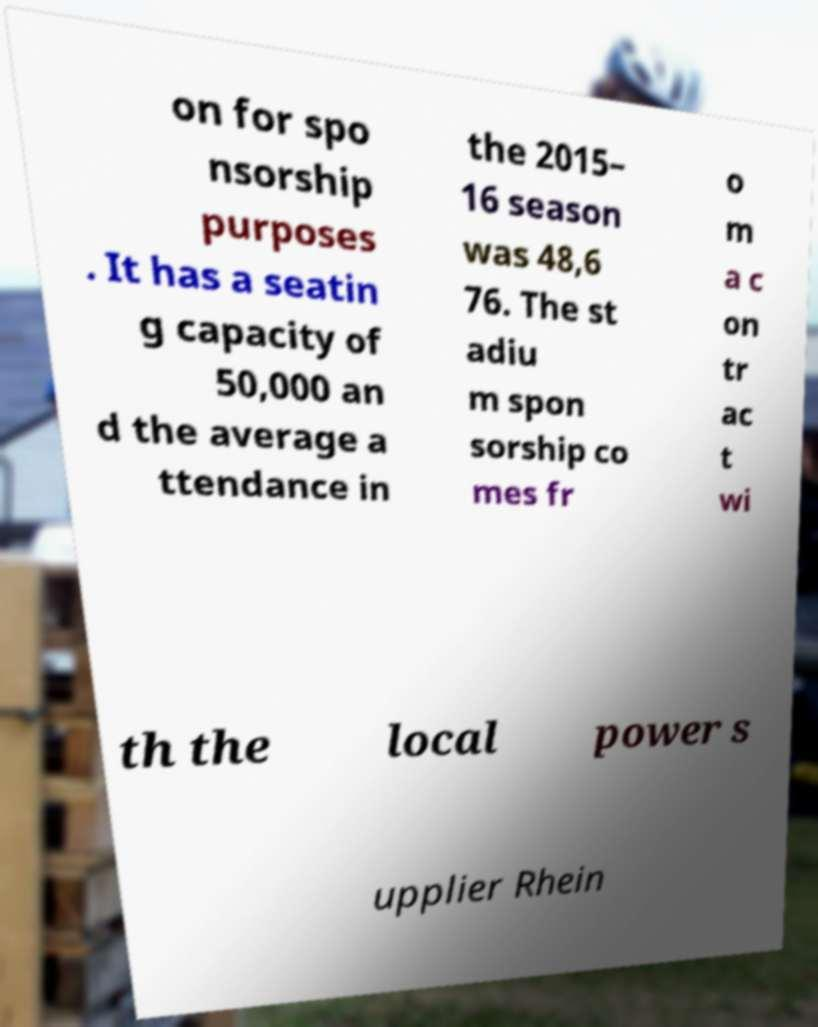Can you read and provide the text displayed in the image?This photo seems to have some interesting text. Can you extract and type it out for me? on for spo nsorship purposes . It has a seatin g capacity of 50,000 an d the average a ttendance in the 2015– 16 season was 48,6 76. The st adiu m spon sorship co mes fr o m a c on tr ac t wi th the local power s upplier Rhein 